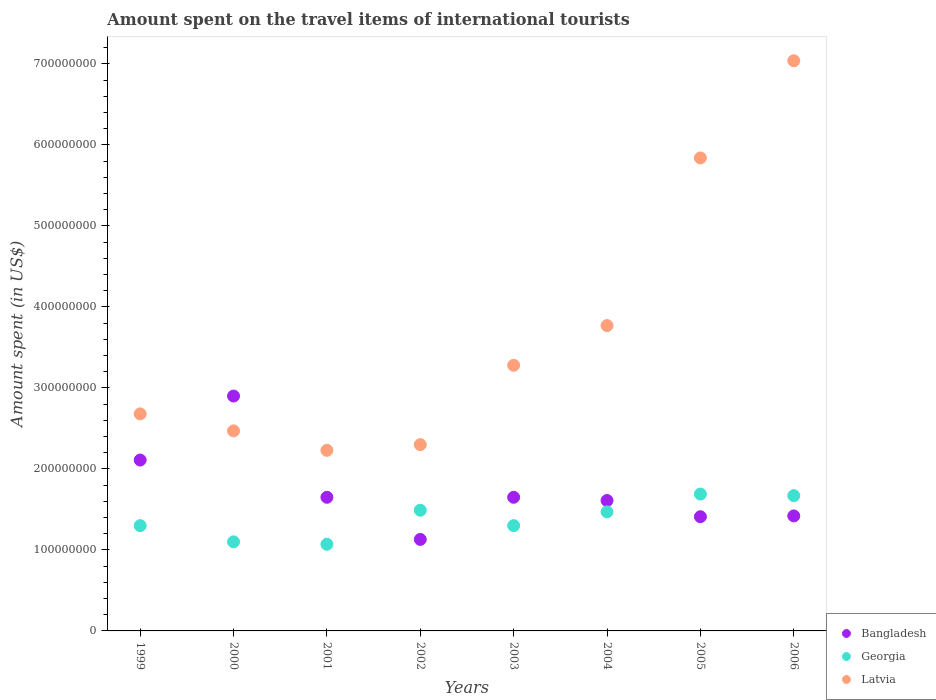How many different coloured dotlines are there?
Your answer should be compact. 3. What is the amount spent on the travel items of international tourists in Latvia in 2002?
Give a very brief answer. 2.30e+08. Across all years, what is the maximum amount spent on the travel items of international tourists in Latvia?
Ensure brevity in your answer.  7.04e+08. Across all years, what is the minimum amount spent on the travel items of international tourists in Latvia?
Keep it short and to the point. 2.23e+08. In which year was the amount spent on the travel items of international tourists in Georgia maximum?
Offer a terse response. 2005. What is the total amount spent on the travel items of international tourists in Georgia in the graph?
Provide a short and direct response. 1.11e+09. What is the difference between the amount spent on the travel items of international tourists in Latvia in 2001 and that in 2006?
Provide a short and direct response. -4.81e+08. What is the difference between the amount spent on the travel items of international tourists in Latvia in 2004 and the amount spent on the travel items of international tourists in Georgia in 2003?
Your answer should be compact. 2.47e+08. What is the average amount spent on the travel items of international tourists in Bangladesh per year?
Offer a very short reply. 1.74e+08. In the year 2001, what is the difference between the amount spent on the travel items of international tourists in Latvia and amount spent on the travel items of international tourists in Bangladesh?
Give a very brief answer. 5.80e+07. What is the ratio of the amount spent on the travel items of international tourists in Bangladesh in 2004 to that in 2005?
Provide a short and direct response. 1.14. Is the amount spent on the travel items of international tourists in Bangladesh in 2001 less than that in 2002?
Your response must be concise. No. Is the difference between the amount spent on the travel items of international tourists in Latvia in 1999 and 2004 greater than the difference between the amount spent on the travel items of international tourists in Bangladesh in 1999 and 2004?
Give a very brief answer. No. What is the difference between the highest and the second highest amount spent on the travel items of international tourists in Bangladesh?
Your response must be concise. 7.90e+07. What is the difference between the highest and the lowest amount spent on the travel items of international tourists in Georgia?
Give a very brief answer. 6.20e+07. Is the sum of the amount spent on the travel items of international tourists in Latvia in 2001 and 2002 greater than the maximum amount spent on the travel items of international tourists in Georgia across all years?
Your answer should be very brief. Yes. Is it the case that in every year, the sum of the amount spent on the travel items of international tourists in Bangladesh and amount spent on the travel items of international tourists in Georgia  is greater than the amount spent on the travel items of international tourists in Latvia?
Your answer should be compact. No. Is the amount spent on the travel items of international tourists in Georgia strictly less than the amount spent on the travel items of international tourists in Bangladesh over the years?
Give a very brief answer. No. How many dotlines are there?
Your response must be concise. 3. How many years are there in the graph?
Your response must be concise. 8. Where does the legend appear in the graph?
Ensure brevity in your answer.  Bottom right. How many legend labels are there?
Your response must be concise. 3. How are the legend labels stacked?
Your answer should be very brief. Vertical. What is the title of the graph?
Provide a short and direct response. Amount spent on the travel items of international tourists. Does "Kuwait" appear as one of the legend labels in the graph?
Provide a short and direct response. No. What is the label or title of the X-axis?
Your response must be concise. Years. What is the label or title of the Y-axis?
Ensure brevity in your answer.  Amount spent (in US$). What is the Amount spent (in US$) in Bangladesh in 1999?
Ensure brevity in your answer.  2.11e+08. What is the Amount spent (in US$) of Georgia in 1999?
Offer a very short reply. 1.30e+08. What is the Amount spent (in US$) in Latvia in 1999?
Make the answer very short. 2.68e+08. What is the Amount spent (in US$) of Bangladesh in 2000?
Offer a terse response. 2.90e+08. What is the Amount spent (in US$) in Georgia in 2000?
Your answer should be very brief. 1.10e+08. What is the Amount spent (in US$) of Latvia in 2000?
Provide a short and direct response. 2.47e+08. What is the Amount spent (in US$) of Bangladesh in 2001?
Your answer should be compact. 1.65e+08. What is the Amount spent (in US$) in Georgia in 2001?
Offer a very short reply. 1.07e+08. What is the Amount spent (in US$) in Latvia in 2001?
Provide a succinct answer. 2.23e+08. What is the Amount spent (in US$) in Bangladesh in 2002?
Your response must be concise. 1.13e+08. What is the Amount spent (in US$) of Georgia in 2002?
Keep it short and to the point. 1.49e+08. What is the Amount spent (in US$) of Latvia in 2002?
Provide a short and direct response. 2.30e+08. What is the Amount spent (in US$) of Bangladesh in 2003?
Keep it short and to the point. 1.65e+08. What is the Amount spent (in US$) in Georgia in 2003?
Provide a short and direct response. 1.30e+08. What is the Amount spent (in US$) in Latvia in 2003?
Your answer should be compact. 3.28e+08. What is the Amount spent (in US$) of Bangladesh in 2004?
Provide a succinct answer. 1.61e+08. What is the Amount spent (in US$) of Georgia in 2004?
Keep it short and to the point. 1.47e+08. What is the Amount spent (in US$) of Latvia in 2004?
Your answer should be compact. 3.77e+08. What is the Amount spent (in US$) of Bangladesh in 2005?
Make the answer very short. 1.41e+08. What is the Amount spent (in US$) of Georgia in 2005?
Provide a succinct answer. 1.69e+08. What is the Amount spent (in US$) in Latvia in 2005?
Keep it short and to the point. 5.84e+08. What is the Amount spent (in US$) of Bangladesh in 2006?
Your response must be concise. 1.42e+08. What is the Amount spent (in US$) in Georgia in 2006?
Your answer should be very brief. 1.67e+08. What is the Amount spent (in US$) of Latvia in 2006?
Ensure brevity in your answer.  7.04e+08. Across all years, what is the maximum Amount spent (in US$) of Bangladesh?
Provide a short and direct response. 2.90e+08. Across all years, what is the maximum Amount spent (in US$) of Georgia?
Your answer should be very brief. 1.69e+08. Across all years, what is the maximum Amount spent (in US$) in Latvia?
Offer a very short reply. 7.04e+08. Across all years, what is the minimum Amount spent (in US$) of Bangladesh?
Offer a terse response. 1.13e+08. Across all years, what is the minimum Amount spent (in US$) in Georgia?
Make the answer very short. 1.07e+08. Across all years, what is the minimum Amount spent (in US$) of Latvia?
Ensure brevity in your answer.  2.23e+08. What is the total Amount spent (in US$) in Bangladesh in the graph?
Provide a succinct answer. 1.39e+09. What is the total Amount spent (in US$) in Georgia in the graph?
Your answer should be compact. 1.11e+09. What is the total Amount spent (in US$) in Latvia in the graph?
Provide a short and direct response. 2.96e+09. What is the difference between the Amount spent (in US$) in Bangladesh in 1999 and that in 2000?
Your response must be concise. -7.90e+07. What is the difference between the Amount spent (in US$) in Georgia in 1999 and that in 2000?
Give a very brief answer. 2.00e+07. What is the difference between the Amount spent (in US$) in Latvia in 1999 and that in 2000?
Provide a short and direct response. 2.10e+07. What is the difference between the Amount spent (in US$) in Bangladesh in 1999 and that in 2001?
Offer a terse response. 4.60e+07. What is the difference between the Amount spent (in US$) in Georgia in 1999 and that in 2001?
Your answer should be very brief. 2.30e+07. What is the difference between the Amount spent (in US$) in Latvia in 1999 and that in 2001?
Your answer should be compact. 4.50e+07. What is the difference between the Amount spent (in US$) of Bangladesh in 1999 and that in 2002?
Your answer should be compact. 9.80e+07. What is the difference between the Amount spent (in US$) in Georgia in 1999 and that in 2002?
Provide a succinct answer. -1.90e+07. What is the difference between the Amount spent (in US$) in Latvia in 1999 and that in 2002?
Keep it short and to the point. 3.80e+07. What is the difference between the Amount spent (in US$) of Bangladesh in 1999 and that in 2003?
Provide a succinct answer. 4.60e+07. What is the difference between the Amount spent (in US$) in Latvia in 1999 and that in 2003?
Your answer should be compact. -6.00e+07. What is the difference between the Amount spent (in US$) of Bangladesh in 1999 and that in 2004?
Make the answer very short. 5.00e+07. What is the difference between the Amount spent (in US$) in Georgia in 1999 and that in 2004?
Your answer should be very brief. -1.70e+07. What is the difference between the Amount spent (in US$) in Latvia in 1999 and that in 2004?
Offer a terse response. -1.09e+08. What is the difference between the Amount spent (in US$) of Bangladesh in 1999 and that in 2005?
Provide a succinct answer. 7.00e+07. What is the difference between the Amount spent (in US$) of Georgia in 1999 and that in 2005?
Offer a terse response. -3.90e+07. What is the difference between the Amount spent (in US$) in Latvia in 1999 and that in 2005?
Make the answer very short. -3.16e+08. What is the difference between the Amount spent (in US$) of Bangladesh in 1999 and that in 2006?
Your response must be concise. 6.90e+07. What is the difference between the Amount spent (in US$) of Georgia in 1999 and that in 2006?
Offer a very short reply. -3.70e+07. What is the difference between the Amount spent (in US$) in Latvia in 1999 and that in 2006?
Provide a succinct answer. -4.36e+08. What is the difference between the Amount spent (in US$) of Bangladesh in 2000 and that in 2001?
Provide a succinct answer. 1.25e+08. What is the difference between the Amount spent (in US$) in Georgia in 2000 and that in 2001?
Make the answer very short. 3.00e+06. What is the difference between the Amount spent (in US$) of Latvia in 2000 and that in 2001?
Provide a short and direct response. 2.40e+07. What is the difference between the Amount spent (in US$) in Bangladesh in 2000 and that in 2002?
Provide a short and direct response. 1.77e+08. What is the difference between the Amount spent (in US$) in Georgia in 2000 and that in 2002?
Your answer should be very brief. -3.90e+07. What is the difference between the Amount spent (in US$) of Latvia in 2000 and that in 2002?
Your response must be concise. 1.70e+07. What is the difference between the Amount spent (in US$) in Bangladesh in 2000 and that in 2003?
Offer a terse response. 1.25e+08. What is the difference between the Amount spent (in US$) of Georgia in 2000 and that in 2003?
Offer a very short reply. -2.00e+07. What is the difference between the Amount spent (in US$) in Latvia in 2000 and that in 2003?
Your response must be concise. -8.10e+07. What is the difference between the Amount spent (in US$) of Bangladesh in 2000 and that in 2004?
Give a very brief answer. 1.29e+08. What is the difference between the Amount spent (in US$) of Georgia in 2000 and that in 2004?
Provide a succinct answer. -3.70e+07. What is the difference between the Amount spent (in US$) in Latvia in 2000 and that in 2004?
Your answer should be compact. -1.30e+08. What is the difference between the Amount spent (in US$) of Bangladesh in 2000 and that in 2005?
Ensure brevity in your answer.  1.49e+08. What is the difference between the Amount spent (in US$) of Georgia in 2000 and that in 2005?
Your response must be concise. -5.90e+07. What is the difference between the Amount spent (in US$) in Latvia in 2000 and that in 2005?
Keep it short and to the point. -3.37e+08. What is the difference between the Amount spent (in US$) of Bangladesh in 2000 and that in 2006?
Keep it short and to the point. 1.48e+08. What is the difference between the Amount spent (in US$) in Georgia in 2000 and that in 2006?
Provide a succinct answer. -5.70e+07. What is the difference between the Amount spent (in US$) in Latvia in 2000 and that in 2006?
Offer a very short reply. -4.57e+08. What is the difference between the Amount spent (in US$) of Bangladesh in 2001 and that in 2002?
Make the answer very short. 5.20e+07. What is the difference between the Amount spent (in US$) in Georgia in 2001 and that in 2002?
Your answer should be compact. -4.20e+07. What is the difference between the Amount spent (in US$) of Latvia in 2001 and that in 2002?
Offer a terse response. -7.00e+06. What is the difference between the Amount spent (in US$) in Georgia in 2001 and that in 2003?
Keep it short and to the point. -2.30e+07. What is the difference between the Amount spent (in US$) of Latvia in 2001 and that in 2003?
Give a very brief answer. -1.05e+08. What is the difference between the Amount spent (in US$) of Bangladesh in 2001 and that in 2004?
Provide a succinct answer. 4.00e+06. What is the difference between the Amount spent (in US$) in Georgia in 2001 and that in 2004?
Your answer should be compact. -4.00e+07. What is the difference between the Amount spent (in US$) of Latvia in 2001 and that in 2004?
Keep it short and to the point. -1.54e+08. What is the difference between the Amount spent (in US$) of Bangladesh in 2001 and that in 2005?
Ensure brevity in your answer.  2.40e+07. What is the difference between the Amount spent (in US$) in Georgia in 2001 and that in 2005?
Ensure brevity in your answer.  -6.20e+07. What is the difference between the Amount spent (in US$) in Latvia in 2001 and that in 2005?
Offer a very short reply. -3.61e+08. What is the difference between the Amount spent (in US$) in Bangladesh in 2001 and that in 2006?
Provide a succinct answer. 2.30e+07. What is the difference between the Amount spent (in US$) in Georgia in 2001 and that in 2006?
Provide a short and direct response. -6.00e+07. What is the difference between the Amount spent (in US$) in Latvia in 2001 and that in 2006?
Your answer should be compact. -4.81e+08. What is the difference between the Amount spent (in US$) of Bangladesh in 2002 and that in 2003?
Your response must be concise. -5.20e+07. What is the difference between the Amount spent (in US$) in Georgia in 2002 and that in 2003?
Offer a very short reply. 1.90e+07. What is the difference between the Amount spent (in US$) in Latvia in 2002 and that in 2003?
Keep it short and to the point. -9.80e+07. What is the difference between the Amount spent (in US$) of Bangladesh in 2002 and that in 2004?
Provide a short and direct response. -4.80e+07. What is the difference between the Amount spent (in US$) in Georgia in 2002 and that in 2004?
Your response must be concise. 2.00e+06. What is the difference between the Amount spent (in US$) of Latvia in 2002 and that in 2004?
Provide a short and direct response. -1.47e+08. What is the difference between the Amount spent (in US$) of Bangladesh in 2002 and that in 2005?
Ensure brevity in your answer.  -2.80e+07. What is the difference between the Amount spent (in US$) of Georgia in 2002 and that in 2005?
Give a very brief answer. -2.00e+07. What is the difference between the Amount spent (in US$) of Latvia in 2002 and that in 2005?
Your answer should be very brief. -3.54e+08. What is the difference between the Amount spent (in US$) of Bangladesh in 2002 and that in 2006?
Your response must be concise. -2.90e+07. What is the difference between the Amount spent (in US$) of Georgia in 2002 and that in 2006?
Ensure brevity in your answer.  -1.80e+07. What is the difference between the Amount spent (in US$) of Latvia in 2002 and that in 2006?
Keep it short and to the point. -4.74e+08. What is the difference between the Amount spent (in US$) in Georgia in 2003 and that in 2004?
Give a very brief answer. -1.70e+07. What is the difference between the Amount spent (in US$) in Latvia in 2003 and that in 2004?
Keep it short and to the point. -4.90e+07. What is the difference between the Amount spent (in US$) in Bangladesh in 2003 and that in 2005?
Your answer should be compact. 2.40e+07. What is the difference between the Amount spent (in US$) in Georgia in 2003 and that in 2005?
Keep it short and to the point. -3.90e+07. What is the difference between the Amount spent (in US$) of Latvia in 2003 and that in 2005?
Give a very brief answer. -2.56e+08. What is the difference between the Amount spent (in US$) in Bangladesh in 2003 and that in 2006?
Your answer should be compact. 2.30e+07. What is the difference between the Amount spent (in US$) of Georgia in 2003 and that in 2006?
Your answer should be compact. -3.70e+07. What is the difference between the Amount spent (in US$) of Latvia in 2003 and that in 2006?
Provide a succinct answer. -3.76e+08. What is the difference between the Amount spent (in US$) in Bangladesh in 2004 and that in 2005?
Your response must be concise. 2.00e+07. What is the difference between the Amount spent (in US$) in Georgia in 2004 and that in 2005?
Make the answer very short. -2.20e+07. What is the difference between the Amount spent (in US$) of Latvia in 2004 and that in 2005?
Give a very brief answer. -2.07e+08. What is the difference between the Amount spent (in US$) in Bangladesh in 2004 and that in 2006?
Your answer should be compact. 1.90e+07. What is the difference between the Amount spent (in US$) of Georgia in 2004 and that in 2006?
Provide a succinct answer. -2.00e+07. What is the difference between the Amount spent (in US$) in Latvia in 2004 and that in 2006?
Provide a succinct answer. -3.27e+08. What is the difference between the Amount spent (in US$) in Georgia in 2005 and that in 2006?
Your answer should be compact. 2.00e+06. What is the difference between the Amount spent (in US$) in Latvia in 2005 and that in 2006?
Your response must be concise. -1.20e+08. What is the difference between the Amount spent (in US$) of Bangladesh in 1999 and the Amount spent (in US$) of Georgia in 2000?
Your answer should be very brief. 1.01e+08. What is the difference between the Amount spent (in US$) of Bangladesh in 1999 and the Amount spent (in US$) of Latvia in 2000?
Your response must be concise. -3.60e+07. What is the difference between the Amount spent (in US$) in Georgia in 1999 and the Amount spent (in US$) in Latvia in 2000?
Provide a short and direct response. -1.17e+08. What is the difference between the Amount spent (in US$) in Bangladesh in 1999 and the Amount spent (in US$) in Georgia in 2001?
Offer a very short reply. 1.04e+08. What is the difference between the Amount spent (in US$) in Bangladesh in 1999 and the Amount spent (in US$) in Latvia in 2001?
Provide a succinct answer. -1.20e+07. What is the difference between the Amount spent (in US$) of Georgia in 1999 and the Amount spent (in US$) of Latvia in 2001?
Provide a succinct answer. -9.30e+07. What is the difference between the Amount spent (in US$) in Bangladesh in 1999 and the Amount spent (in US$) in Georgia in 2002?
Provide a succinct answer. 6.20e+07. What is the difference between the Amount spent (in US$) of Bangladesh in 1999 and the Amount spent (in US$) of Latvia in 2002?
Provide a succinct answer. -1.90e+07. What is the difference between the Amount spent (in US$) in Georgia in 1999 and the Amount spent (in US$) in Latvia in 2002?
Your response must be concise. -1.00e+08. What is the difference between the Amount spent (in US$) in Bangladesh in 1999 and the Amount spent (in US$) in Georgia in 2003?
Offer a terse response. 8.10e+07. What is the difference between the Amount spent (in US$) of Bangladesh in 1999 and the Amount spent (in US$) of Latvia in 2003?
Give a very brief answer. -1.17e+08. What is the difference between the Amount spent (in US$) in Georgia in 1999 and the Amount spent (in US$) in Latvia in 2003?
Your answer should be very brief. -1.98e+08. What is the difference between the Amount spent (in US$) in Bangladesh in 1999 and the Amount spent (in US$) in Georgia in 2004?
Give a very brief answer. 6.40e+07. What is the difference between the Amount spent (in US$) in Bangladesh in 1999 and the Amount spent (in US$) in Latvia in 2004?
Offer a very short reply. -1.66e+08. What is the difference between the Amount spent (in US$) of Georgia in 1999 and the Amount spent (in US$) of Latvia in 2004?
Your answer should be compact. -2.47e+08. What is the difference between the Amount spent (in US$) of Bangladesh in 1999 and the Amount spent (in US$) of Georgia in 2005?
Keep it short and to the point. 4.20e+07. What is the difference between the Amount spent (in US$) in Bangladesh in 1999 and the Amount spent (in US$) in Latvia in 2005?
Keep it short and to the point. -3.73e+08. What is the difference between the Amount spent (in US$) of Georgia in 1999 and the Amount spent (in US$) of Latvia in 2005?
Your answer should be very brief. -4.54e+08. What is the difference between the Amount spent (in US$) of Bangladesh in 1999 and the Amount spent (in US$) of Georgia in 2006?
Provide a short and direct response. 4.40e+07. What is the difference between the Amount spent (in US$) in Bangladesh in 1999 and the Amount spent (in US$) in Latvia in 2006?
Offer a terse response. -4.93e+08. What is the difference between the Amount spent (in US$) in Georgia in 1999 and the Amount spent (in US$) in Latvia in 2006?
Make the answer very short. -5.74e+08. What is the difference between the Amount spent (in US$) in Bangladesh in 2000 and the Amount spent (in US$) in Georgia in 2001?
Ensure brevity in your answer.  1.83e+08. What is the difference between the Amount spent (in US$) in Bangladesh in 2000 and the Amount spent (in US$) in Latvia in 2001?
Make the answer very short. 6.70e+07. What is the difference between the Amount spent (in US$) in Georgia in 2000 and the Amount spent (in US$) in Latvia in 2001?
Make the answer very short. -1.13e+08. What is the difference between the Amount spent (in US$) in Bangladesh in 2000 and the Amount spent (in US$) in Georgia in 2002?
Your answer should be compact. 1.41e+08. What is the difference between the Amount spent (in US$) of Bangladesh in 2000 and the Amount spent (in US$) of Latvia in 2002?
Provide a succinct answer. 6.00e+07. What is the difference between the Amount spent (in US$) of Georgia in 2000 and the Amount spent (in US$) of Latvia in 2002?
Make the answer very short. -1.20e+08. What is the difference between the Amount spent (in US$) in Bangladesh in 2000 and the Amount spent (in US$) in Georgia in 2003?
Make the answer very short. 1.60e+08. What is the difference between the Amount spent (in US$) of Bangladesh in 2000 and the Amount spent (in US$) of Latvia in 2003?
Ensure brevity in your answer.  -3.80e+07. What is the difference between the Amount spent (in US$) in Georgia in 2000 and the Amount spent (in US$) in Latvia in 2003?
Your answer should be compact. -2.18e+08. What is the difference between the Amount spent (in US$) of Bangladesh in 2000 and the Amount spent (in US$) of Georgia in 2004?
Offer a terse response. 1.43e+08. What is the difference between the Amount spent (in US$) of Bangladesh in 2000 and the Amount spent (in US$) of Latvia in 2004?
Offer a terse response. -8.70e+07. What is the difference between the Amount spent (in US$) of Georgia in 2000 and the Amount spent (in US$) of Latvia in 2004?
Offer a very short reply. -2.67e+08. What is the difference between the Amount spent (in US$) in Bangladesh in 2000 and the Amount spent (in US$) in Georgia in 2005?
Your response must be concise. 1.21e+08. What is the difference between the Amount spent (in US$) in Bangladesh in 2000 and the Amount spent (in US$) in Latvia in 2005?
Give a very brief answer. -2.94e+08. What is the difference between the Amount spent (in US$) in Georgia in 2000 and the Amount spent (in US$) in Latvia in 2005?
Make the answer very short. -4.74e+08. What is the difference between the Amount spent (in US$) in Bangladesh in 2000 and the Amount spent (in US$) in Georgia in 2006?
Make the answer very short. 1.23e+08. What is the difference between the Amount spent (in US$) of Bangladesh in 2000 and the Amount spent (in US$) of Latvia in 2006?
Ensure brevity in your answer.  -4.14e+08. What is the difference between the Amount spent (in US$) of Georgia in 2000 and the Amount spent (in US$) of Latvia in 2006?
Ensure brevity in your answer.  -5.94e+08. What is the difference between the Amount spent (in US$) of Bangladesh in 2001 and the Amount spent (in US$) of Georgia in 2002?
Provide a succinct answer. 1.60e+07. What is the difference between the Amount spent (in US$) of Bangladesh in 2001 and the Amount spent (in US$) of Latvia in 2002?
Provide a succinct answer. -6.50e+07. What is the difference between the Amount spent (in US$) of Georgia in 2001 and the Amount spent (in US$) of Latvia in 2002?
Keep it short and to the point. -1.23e+08. What is the difference between the Amount spent (in US$) in Bangladesh in 2001 and the Amount spent (in US$) in Georgia in 2003?
Your response must be concise. 3.50e+07. What is the difference between the Amount spent (in US$) of Bangladesh in 2001 and the Amount spent (in US$) of Latvia in 2003?
Offer a terse response. -1.63e+08. What is the difference between the Amount spent (in US$) in Georgia in 2001 and the Amount spent (in US$) in Latvia in 2003?
Provide a succinct answer. -2.21e+08. What is the difference between the Amount spent (in US$) in Bangladesh in 2001 and the Amount spent (in US$) in Georgia in 2004?
Ensure brevity in your answer.  1.80e+07. What is the difference between the Amount spent (in US$) in Bangladesh in 2001 and the Amount spent (in US$) in Latvia in 2004?
Your answer should be compact. -2.12e+08. What is the difference between the Amount spent (in US$) of Georgia in 2001 and the Amount spent (in US$) of Latvia in 2004?
Your answer should be very brief. -2.70e+08. What is the difference between the Amount spent (in US$) in Bangladesh in 2001 and the Amount spent (in US$) in Georgia in 2005?
Provide a short and direct response. -4.00e+06. What is the difference between the Amount spent (in US$) of Bangladesh in 2001 and the Amount spent (in US$) of Latvia in 2005?
Your response must be concise. -4.19e+08. What is the difference between the Amount spent (in US$) in Georgia in 2001 and the Amount spent (in US$) in Latvia in 2005?
Provide a succinct answer. -4.77e+08. What is the difference between the Amount spent (in US$) of Bangladesh in 2001 and the Amount spent (in US$) of Latvia in 2006?
Make the answer very short. -5.39e+08. What is the difference between the Amount spent (in US$) of Georgia in 2001 and the Amount spent (in US$) of Latvia in 2006?
Your response must be concise. -5.97e+08. What is the difference between the Amount spent (in US$) in Bangladesh in 2002 and the Amount spent (in US$) in Georgia in 2003?
Keep it short and to the point. -1.70e+07. What is the difference between the Amount spent (in US$) of Bangladesh in 2002 and the Amount spent (in US$) of Latvia in 2003?
Keep it short and to the point. -2.15e+08. What is the difference between the Amount spent (in US$) in Georgia in 2002 and the Amount spent (in US$) in Latvia in 2003?
Provide a short and direct response. -1.79e+08. What is the difference between the Amount spent (in US$) of Bangladesh in 2002 and the Amount spent (in US$) of Georgia in 2004?
Your answer should be very brief. -3.40e+07. What is the difference between the Amount spent (in US$) in Bangladesh in 2002 and the Amount spent (in US$) in Latvia in 2004?
Ensure brevity in your answer.  -2.64e+08. What is the difference between the Amount spent (in US$) of Georgia in 2002 and the Amount spent (in US$) of Latvia in 2004?
Provide a short and direct response. -2.28e+08. What is the difference between the Amount spent (in US$) of Bangladesh in 2002 and the Amount spent (in US$) of Georgia in 2005?
Give a very brief answer. -5.60e+07. What is the difference between the Amount spent (in US$) of Bangladesh in 2002 and the Amount spent (in US$) of Latvia in 2005?
Offer a terse response. -4.71e+08. What is the difference between the Amount spent (in US$) in Georgia in 2002 and the Amount spent (in US$) in Latvia in 2005?
Ensure brevity in your answer.  -4.35e+08. What is the difference between the Amount spent (in US$) in Bangladesh in 2002 and the Amount spent (in US$) in Georgia in 2006?
Ensure brevity in your answer.  -5.40e+07. What is the difference between the Amount spent (in US$) in Bangladesh in 2002 and the Amount spent (in US$) in Latvia in 2006?
Offer a terse response. -5.91e+08. What is the difference between the Amount spent (in US$) in Georgia in 2002 and the Amount spent (in US$) in Latvia in 2006?
Your answer should be very brief. -5.55e+08. What is the difference between the Amount spent (in US$) of Bangladesh in 2003 and the Amount spent (in US$) of Georgia in 2004?
Offer a terse response. 1.80e+07. What is the difference between the Amount spent (in US$) of Bangladesh in 2003 and the Amount spent (in US$) of Latvia in 2004?
Your response must be concise. -2.12e+08. What is the difference between the Amount spent (in US$) of Georgia in 2003 and the Amount spent (in US$) of Latvia in 2004?
Provide a succinct answer. -2.47e+08. What is the difference between the Amount spent (in US$) of Bangladesh in 2003 and the Amount spent (in US$) of Georgia in 2005?
Give a very brief answer. -4.00e+06. What is the difference between the Amount spent (in US$) in Bangladesh in 2003 and the Amount spent (in US$) in Latvia in 2005?
Your answer should be very brief. -4.19e+08. What is the difference between the Amount spent (in US$) in Georgia in 2003 and the Amount spent (in US$) in Latvia in 2005?
Offer a very short reply. -4.54e+08. What is the difference between the Amount spent (in US$) of Bangladesh in 2003 and the Amount spent (in US$) of Latvia in 2006?
Your response must be concise. -5.39e+08. What is the difference between the Amount spent (in US$) of Georgia in 2003 and the Amount spent (in US$) of Latvia in 2006?
Make the answer very short. -5.74e+08. What is the difference between the Amount spent (in US$) in Bangladesh in 2004 and the Amount spent (in US$) in Georgia in 2005?
Ensure brevity in your answer.  -8.00e+06. What is the difference between the Amount spent (in US$) in Bangladesh in 2004 and the Amount spent (in US$) in Latvia in 2005?
Provide a short and direct response. -4.23e+08. What is the difference between the Amount spent (in US$) of Georgia in 2004 and the Amount spent (in US$) of Latvia in 2005?
Provide a succinct answer. -4.37e+08. What is the difference between the Amount spent (in US$) of Bangladesh in 2004 and the Amount spent (in US$) of Georgia in 2006?
Provide a succinct answer. -6.00e+06. What is the difference between the Amount spent (in US$) in Bangladesh in 2004 and the Amount spent (in US$) in Latvia in 2006?
Offer a very short reply. -5.43e+08. What is the difference between the Amount spent (in US$) of Georgia in 2004 and the Amount spent (in US$) of Latvia in 2006?
Provide a succinct answer. -5.57e+08. What is the difference between the Amount spent (in US$) in Bangladesh in 2005 and the Amount spent (in US$) in Georgia in 2006?
Your answer should be very brief. -2.60e+07. What is the difference between the Amount spent (in US$) in Bangladesh in 2005 and the Amount spent (in US$) in Latvia in 2006?
Ensure brevity in your answer.  -5.63e+08. What is the difference between the Amount spent (in US$) in Georgia in 2005 and the Amount spent (in US$) in Latvia in 2006?
Provide a short and direct response. -5.35e+08. What is the average Amount spent (in US$) in Bangladesh per year?
Keep it short and to the point. 1.74e+08. What is the average Amount spent (in US$) of Georgia per year?
Provide a short and direct response. 1.39e+08. What is the average Amount spent (in US$) of Latvia per year?
Keep it short and to the point. 3.70e+08. In the year 1999, what is the difference between the Amount spent (in US$) in Bangladesh and Amount spent (in US$) in Georgia?
Your response must be concise. 8.10e+07. In the year 1999, what is the difference between the Amount spent (in US$) of Bangladesh and Amount spent (in US$) of Latvia?
Ensure brevity in your answer.  -5.70e+07. In the year 1999, what is the difference between the Amount spent (in US$) in Georgia and Amount spent (in US$) in Latvia?
Your answer should be compact. -1.38e+08. In the year 2000, what is the difference between the Amount spent (in US$) in Bangladesh and Amount spent (in US$) in Georgia?
Provide a succinct answer. 1.80e+08. In the year 2000, what is the difference between the Amount spent (in US$) of Bangladesh and Amount spent (in US$) of Latvia?
Your answer should be very brief. 4.30e+07. In the year 2000, what is the difference between the Amount spent (in US$) of Georgia and Amount spent (in US$) of Latvia?
Make the answer very short. -1.37e+08. In the year 2001, what is the difference between the Amount spent (in US$) in Bangladesh and Amount spent (in US$) in Georgia?
Your answer should be compact. 5.80e+07. In the year 2001, what is the difference between the Amount spent (in US$) in Bangladesh and Amount spent (in US$) in Latvia?
Your response must be concise. -5.80e+07. In the year 2001, what is the difference between the Amount spent (in US$) in Georgia and Amount spent (in US$) in Latvia?
Offer a terse response. -1.16e+08. In the year 2002, what is the difference between the Amount spent (in US$) in Bangladesh and Amount spent (in US$) in Georgia?
Your answer should be compact. -3.60e+07. In the year 2002, what is the difference between the Amount spent (in US$) in Bangladesh and Amount spent (in US$) in Latvia?
Give a very brief answer. -1.17e+08. In the year 2002, what is the difference between the Amount spent (in US$) in Georgia and Amount spent (in US$) in Latvia?
Provide a short and direct response. -8.10e+07. In the year 2003, what is the difference between the Amount spent (in US$) of Bangladesh and Amount spent (in US$) of Georgia?
Provide a succinct answer. 3.50e+07. In the year 2003, what is the difference between the Amount spent (in US$) in Bangladesh and Amount spent (in US$) in Latvia?
Offer a very short reply. -1.63e+08. In the year 2003, what is the difference between the Amount spent (in US$) in Georgia and Amount spent (in US$) in Latvia?
Keep it short and to the point. -1.98e+08. In the year 2004, what is the difference between the Amount spent (in US$) of Bangladesh and Amount spent (in US$) of Georgia?
Your response must be concise. 1.40e+07. In the year 2004, what is the difference between the Amount spent (in US$) of Bangladesh and Amount spent (in US$) of Latvia?
Make the answer very short. -2.16e+08. In the year 2004, what is the difference between the Amount spent (in US$) in Georgia and Amount spent (in US$) in Latvia?
Offer a very short reply. -2.30e+08. In the year 2005, what is the difference between the Amount spent (in US$) of Bangladesh and Amount spent (in US$) of Georgia?
Offer a terse response. -2.80e+07. In the year 2005, what is the difference between the Amount spent (in US$) of Bangladesh and Amount spent (in US$) of Latvia?
Your answer should be compact. -4.43e+08. In the year 2005, what is the difference between the Amount spent (in US$) of Georgia and Amount spent (in US$) of Latvia?
Offer a terse response. -4.15e+08. In the year 2006, what is the difference between the Amount spent (in US$) in Bangladesh and Amount spent (in US$) in Georgia?
Offer a very short reply. -2.50e+07. In the year 2006, what is the difference between the Amount spent (in US$) of Bangladesh and Amount spent (in US$) of Latvia?
Offer a very short reply. -5.62e+08. In the year 2006, what is the difference between the Amount spent (in US$) in Georgia and Amount spent (in US$) in Latvia?
Offer a very short reply. -5.37e+08. What is the ratio of the Amount spent (in US$) in Bangladesh in 1999 to that in 2000?
Ensure brevity in your answer.  0.73. What is the ratio of the Amount spent (in US$) of Georgia in 1999 to that in 2000?
Offer a very short reply. 1.18. What is the ratio of the Amount spent (in US$) in Latvia in 1999 to that in 2000?
Provide a short and direct response. 1.08. What is the ratio of the Amount spent (in US$) of Bangladesh in 1999 to that in 2001?
Make the answer very short. 1.28. What is the ratio of the Amount spent (in US$) in Georgia in 1999 to that in 2001?
Your response must be concise. 1.22. What is the ratio of the Amount spent (in US$) in Latvia in 1999 to that in 2001?
Provide a succinct answer. 1.2. What is the ratio of the Amount spent (in US$) in Bangladesh in 1999 to that in 2002?
Your answer should be compact. 1.87. What is the ratio of the Amount spent (in US$) in Georgia in 1999 to that in 2002?
Your answer should be very brief. 0.87. What is the ratio of the Amount spent (in US$) of Latvia in 1999 to that in 2002?
Ensure brevity in your answer.  1.17. What is the ratio of the Amount spent (in US$) in Bangladesh in 1999 to that in 2003?
Make the answer very short. 1.28. What is the ratio of the Amount spent (in US$) in Latvia in 1999 to that in 2003?
Your response must be concise. 0.82. What is the ratio of the Amount spent (in US$) of Bangladesh in 1999 to that in 2004?
Make the answer very short. 1.31. What is the ratio of the Amount spent (in US$) in Georgia in 1999 to that in 2004?
Your answer should be very brief. 0.88. What is the ratio of the Amount spent (in US$) of Latvia in 1999 to that in 2004?
Give a very brief answer. 0.71. What is the ratio of the Amount spent (in US$) in Bangladesh in 1999 to that in 2005?
Make the answer very short. 1.5. What is the ratio of the Amount spent (in US$) of Georgia in 1999 to that in 2005?
Offer a very short reply. 0.77. What is the ratio of the Amount spent (in US$) of Latvia in 1999 to that in 2005?
Make the answer very short. 0.46. What is the ratio of the Amount spent (in US$) in Bangladesh in 1999 to that in 2006?
Provide a short and direct response. 1.49. What is the ratio of the Amount spent (in US$) of Georgia in 1999 to that in 2006?
Your answer should be very brief. 0.78. What is the ratio of the Amount spent (in US$) of Latvia in 1999 to that in 2006?
Your answer should be very brief. 0.38. What is the ratio of the Amount spent (in US$) of Bangladesh in 2000 to that in 2001?
Provide a succinct answer. 1.76. What is the ratio of the Amount spent (in US$) in Georgia in 2000 to that in 2001?
Your response must be concise. 1.03. What is the ratio of the Amount spent (in US$) in Latvia in 2000 to that in 2001?
Your answer should be very brief. 1.11. What is the ratio of the Amount spent (in US$) in Bangladesh in 2000 to that in 2002?
Your response must be concise. 2.57. What is the ratio of the Amount spent (in US$) in Georgia in 2000 to that in 2002?
Your answer should be compact. 0.74. What is the ratio of the Amount spent (in US$) of Latvia in 2000 to that in 2002?
Keep it short and to the point. 1.07. What is the ratio of the Amount spent (in US$) of Bangladesh in 2000 to that in 2003?
Provide a succinct answer. 1.76. What is the ratio of the Amount spent (in US$) in Georgia in 2000 to that in 2003?
Keep it short and to the point. 0.85. What is the ratio of the Amount spent (in US$) of Latvia in 2000 to that in 2003?
Your answer should be compact. 0.75. What is the ratio of the Amount spent (in US$) in Bangladesh in 2000 to that in 2004?
Keep it short and to the point. 1.8. What is the ratio of the Amount spent (in US$) in Georgia in 2000 to that in 2004?
Give a very brief answer. 0.75. What is the ratio of the Amount spent (in US$) in Latvia in 2000 to that in 2004?
Offer a very short reply. 0.66. What is the ratio of the Amount spent (in US$) of Bangladesh in 2000 to that in 2005?
Make the answer very short. 2.06. What is the ratio of the Amount spent (in US$) in Georgia in 2000 to that in 2005?
Offer a very short reply. 0.65. What is the ratio of the Amount spent (in US$) of Latvia in 2000 to that in 2005?
Your response must be concise. 0.42. What is the ratio of the Amount spent (in US$) of Bangladesh in 2000 to that in 2006?
Give a very brief answer. 2.04. What is the ratio of the Amount spent (in US$) in Georgia in 2000 to that in 2006?
Offer a very short reply. 0.66. What is the ratio of the Amount spent (in US$) of Latvia in 2000 to that in 2006?
Make the answer very short. 0.35. What is the ratio of the Amount spent (in US$) in Bangladesh in 2001 to that in 2002?
Your response must be concise. 1.46. What is the ratio of the Amount spent (in US$) of Georgia in 2001 to that in 2002?
Provide a short and direct response. 0.72. What is the ratio of the Amount spent (in US$) of Latvia in 2001 to that in 2002?
Your answer should be very brief. 0.97. What is the ratio of the Amount spent (in US$) of Georgia in 2001 to that in 2003?
Your response must be concise. 0.82. What is the ratio of the Amount spent (in US$) of Latvia in 2001 to that in 2003?
Your answer should be compact. 0.68. What is the ratio of the Amount spent (in US$) in Bangladesh in 2001 to that in 2004?
Ensure brevity in your answer.  1.02. What is the ratio of the Amount spent (in US$) in Georgia in 2001 to that in 2004?
Your answer should be compact. 0.73. What is the ratio of the Amount spent (in US$) in Latvia in 2001 to that in 2004?
Offer a very short reply. 0.59. What is the ratio of the Amount spent (in US$) in Bangladesh in 2001 to that in 2005?
Your answer should be compact. 1.17. What is the ratio of the Amount spent (in US$) of Georgia in 2001 to that in 2005?
Give a very brief answer. 0.63. What is the ratio of the Amount spent (in US$) in Latvia in 2001 to that in 2005?
Make the answer very short. 0.38. What is the ratio of the Amount spent (in US$) of Bangladesh in 2001 to that in 2006?
Provide a short and direct response. 1.16. What is the ratio of the Amount spent (in US$) in Georgia in 2001 to that in 2006?
Offer a very short reply. 0.64. What is the ratio of the Amount spent (in US$) of Latvia in 2001 to that in 2006?
Offer a terse response. 0.32. What is the ratio of the Amount spent (in US$) in Bangladesh in 2002 to that in 2003?
Offer a very short reply. 0.68. What is the ratio of the Amount spent (in US$) in Georgia in 2002 to that in 2003?
Offer a terse response. 1.15. What is the ratio of the Amount spent (in US$) in Latvia in 2002 to that in 2003?
Provide a succinct answer. 0.7. What is the ratio of the Amount spent (in US$) of Bangladesh in 2002 to that in 2004?
Your response must be concise. 0.7. What is the ratio of the Amount spent (in US$) of Georgia in 2002 to that in 2004?
Your answer should be very brief. 1.01. What is the ratio of the Amount spent (in US$) in Latvia in 2002 to that in 2004?
Offer a very short reply. 0.61. What is the ratio of the Amount spent (in US$) of Bangladesh in 2002 to that in 2005?
Make the answer very short. 0.8. What is the ratio of the Amount spent (in US$) in Georgia in 2002 to that in 2005?
Your answer should be compact. 0.88. What is the ratio of the Amount spent (in US$) in Latvia in 2002 to that in 2005?
Keep it short and to the point. 0.39. What is the ratio of the Amount spent (in US$) in Bangladesh in 2002 to that in 2006?
Ensure brevity in your answer.  0.8. What is the ratio of the Amount spent (in US$) in Georgia in 2002 to that in 2006?
Offer a terse response. 0.89. What is the ratio of the Amount spent (in US$) of Latvia in 2002 to that in 2006?
Give a very brief answer. 0.33. What is the ratio of the Amount spent (in US$) in Bangladesh in 2003 to that in 2004?
Your response must be concise. 1.02. What is the ratio of the Amount spent (in US$) in Georgia in 2003 to that in 2004?
Provide a short and direct response. 0.88. What is the ratio of the Amount spent (in US$) of Latvia in 2003 to that in 2004?
Provide a succinct answer. 0.87. What is the ratio of the Amount spent (in US$) in Bangladesh in 2003 to that in 2005?
Your answer should be very brief. 1.17. What is the ratio of the Amount spent (in US$) of Georgia in 2003 to that in 2005?
Offer a very short reply. 0.77. What is the ratio of the Amount spent (in US$) in Latvia in 2003 to that in 2005?
Your response must be concise. 0.56. What is the ratio of the Amount spent (in US$) in Bangladesh in 2003 to that in 2006?
Your answer should be very brief. 1.16. What is the ratio of the Amount spent (in US$) of Georgia in 2003 to that in 2006?
Provide a succinct answer. 0.78. What is the ratio of the Amount spent (in US$) of Latvia in 2003 to that in 2006?
Your answer should be compact. 0.47. What is the ratio of the Amount spent (in US$) in Bangladesh in 2004 to that in 2005?
Provide a short and direct response. 1.14. What is the ratio of the Amount spent (in US$) in Georgia in 2004 to that in 2005?
Offer a terse response. 0.87. What is the ratio of the Amount spent (in US$) of Latvia in 2004 to that in 2005?
Offer a terse response. 0.65. What is the ratio of the Amount spent (in US$) in Bangladesh in 2004 to that in 2006?
Provide a short and direct response. 1.13. What is the ratio of the Amount spent (in US$) of Georgia in 2004 to that in 2006?
Ensure brevity in your answer.  0.88. What is the ratio of the Amount spent (in US$) in Latvia in 2004 to that in 2006?
Provide a succinct answer. 0.54. What is the ratio of the Amount spent (in US$) in Bangladesh in 2005 to that in 2006?
Make the answer very short. 0.99. What is the ratio of the Amount spent (in US$) in Georgia in 2005 to that in 2006?
Make the answer very short. 1.01. What is the ratio of the Amount spent (in US$) of Latvia in 2005 to that in 2006?
Provide a short and direct response. 0.83. What is the difference between the highest and the second highest Amount spent (in US$) in Bangladesh?
Give a very brief answer. 7.90e+07. What is the difference between the highest and the second highest Amount spent (in US$) in Latvia?
Make the answer very short. 1.20e+08. What is the difference between the highest and the lowest Amount spent (in US$) of Bangladesh?
Offer a terse response. 1.77e+08. What is the difference between the highest and the lowest Amount spent (in US$) in Georgia?
Make the answer very short. 6.20e+07. What is the difference between the highest and the lowest Amount spent (in US$) of Latvia?
Your response must be concise. 4.81e+08. 